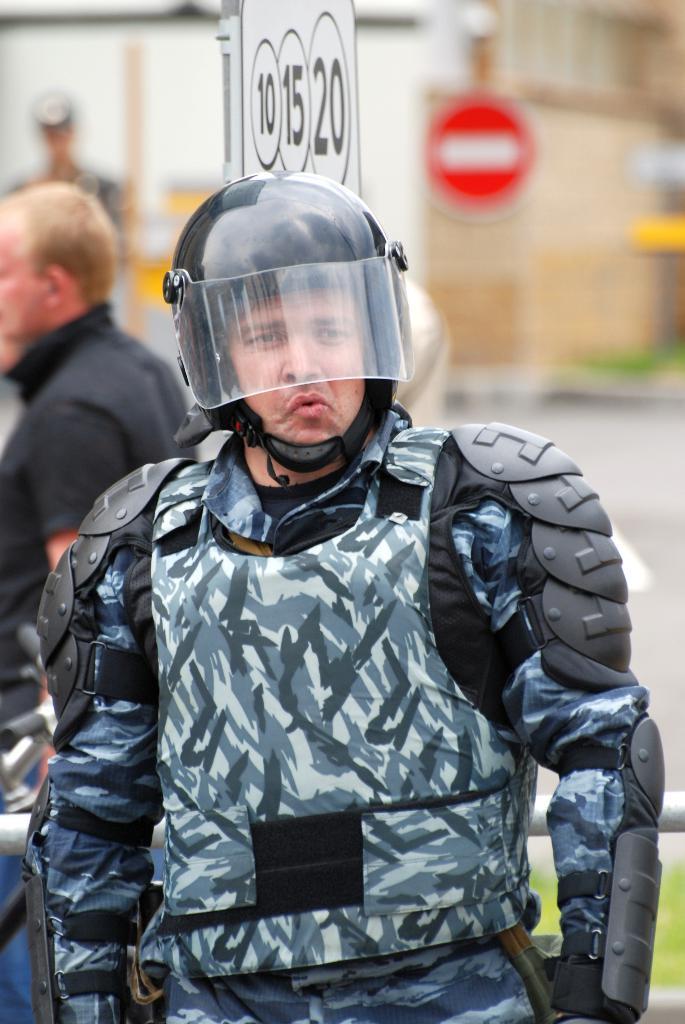How would you summarize this image in a sentence or two? In this image, there is a person standing and wearing a black color helmet, at the background there is a man standing and there is a white color board, there is a building. 